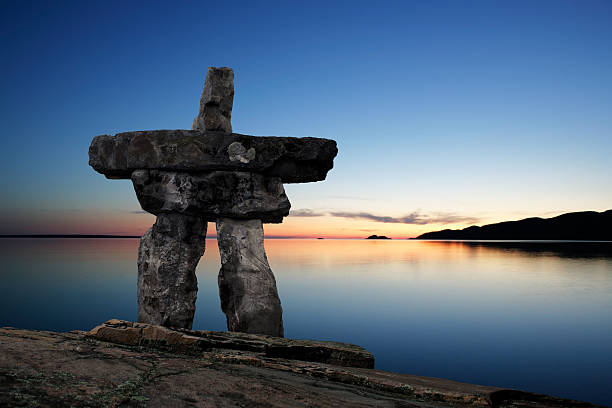Could you write a poem about this image? Upon the quiet shore it stands,
A sentinel of rock and lands,
Inukshuk in the twilight hour,
Sturdy form with silent power.

Beneath the sky, in hues so grand,
It watches over sea and sand,
The sunset paints with gentle brush,
A world in stillness, evening hush.

The waves reflect the heavens bright,
A mirror of the fading light,
And in the calm, a timeless lore,
Of nature’s peace forevermore.

O Inukshuk, guardian true,
What tales have skies and waters told to you?
In silence you stand, through night and day,
A guide for those who’ve lost their way. Imagine a story where this Inukshuk is a portal to another world. What happens? One evening, as the sun dipped below the horizon, casting its last golden rays upon the Inukshuk, a soft hum filled the air. The stones began to glow with an ethereal light, revealing an ancient inscription that had long been eroded by time. Curious, a young explorer who had been photographing the sunset approached the Inukshuk. As they touched the glowing stone, the world around them blurred and shifted. In the blink of an eye, they found themselves in a different realm—a land of towering crystalline structures that shimmered with every color of the rainbow. In this new world, the laws of physics seemed to bend, and creatures of pure light danced around them. The explorer discovered that the Inukshuk served as a gateway to this mystical dimension, connecting the wisdom of the Inuit traditions with the boundless creativity and energy of this otherworldly place. Each visit through the portal unveiled new wonders and deeper understandings, bridging two worlds in a shared harmony of existence. Describe the scene if there was a light snow starting to fall. With the onset of twilight, delicate snowflakes begin to drift down from the heavens, transforming the serene sunset scene into a winter wonderland. The tranquil water, now reflecting the soft glow of the evening, becomes a canvas for the falling snow. Each flake lands gently on the rough stones of the Inukshuk, dusting it with a powdery white blanket. The air grows crisp, and the gentle hush of the snowfall adds to the scene’s tranquility. The snowy landscape, combined with the colorful sky, creates a breathtaking blend of warmth and coolness, as if the world is being gently wrapped in a serene, wintry embrace. 